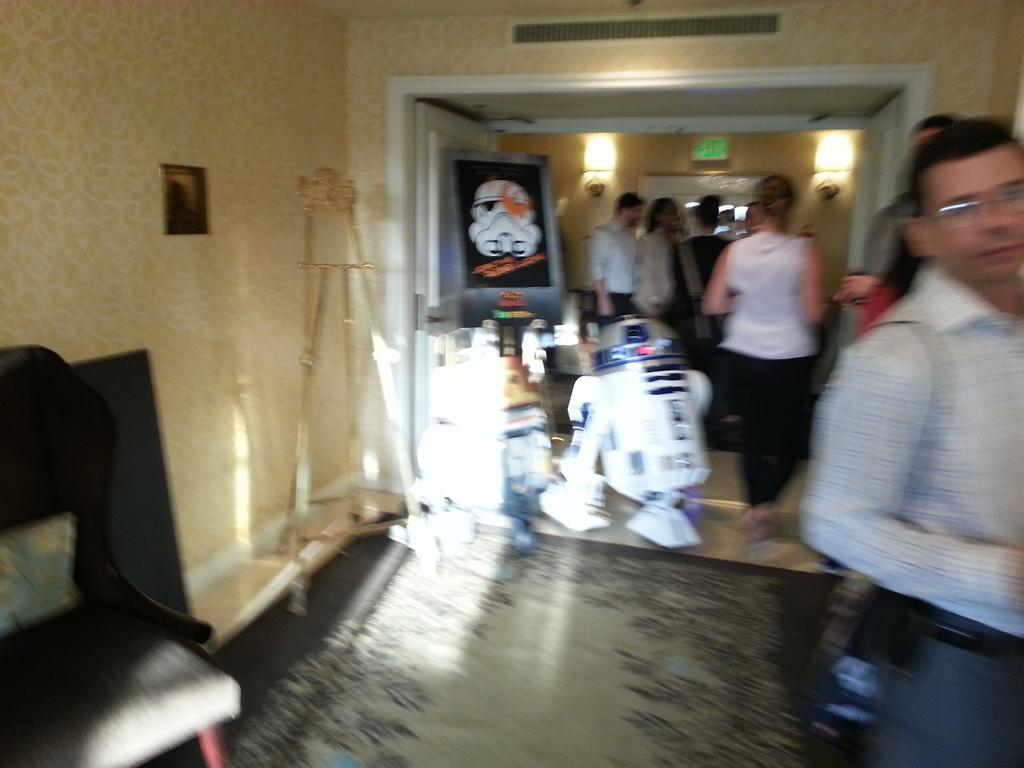Describe this image in one or two sentences. In this image I can see few people,chair,white color objects and few objects on the floor. The wall is in cream color and it is blurred. 